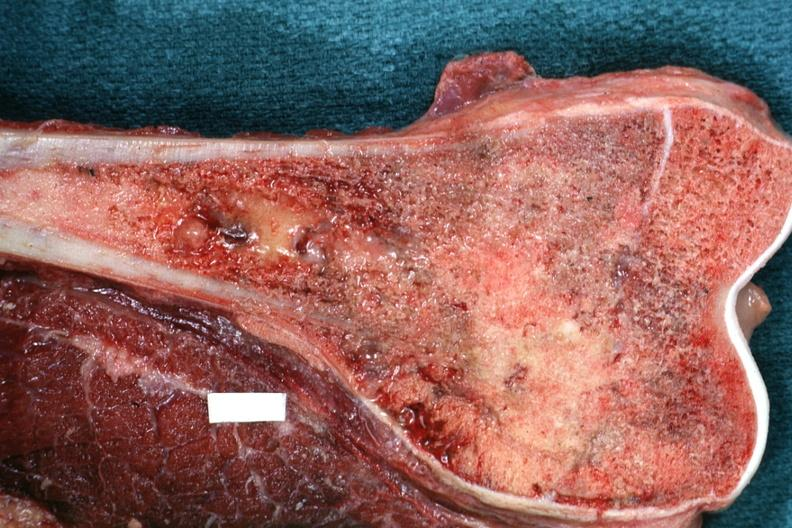what is distal end excellent example?
Answer the question using a single word or phrase. Sectioned femur lesion 